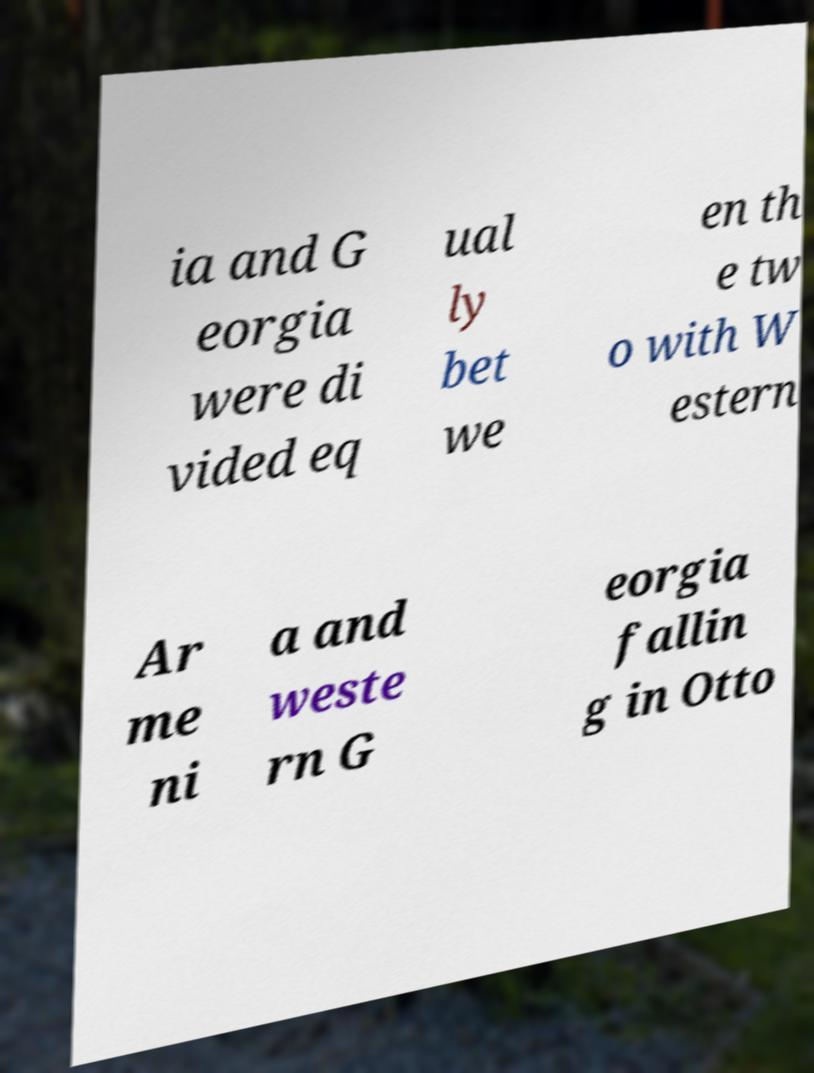Please read and relay the text visible in this image. What does it say? ia and G eorgia were di vided eq ual ly bet we en th e tw o with W estern Ar me ni a and weste rn G eorgia fallin g in Otto 